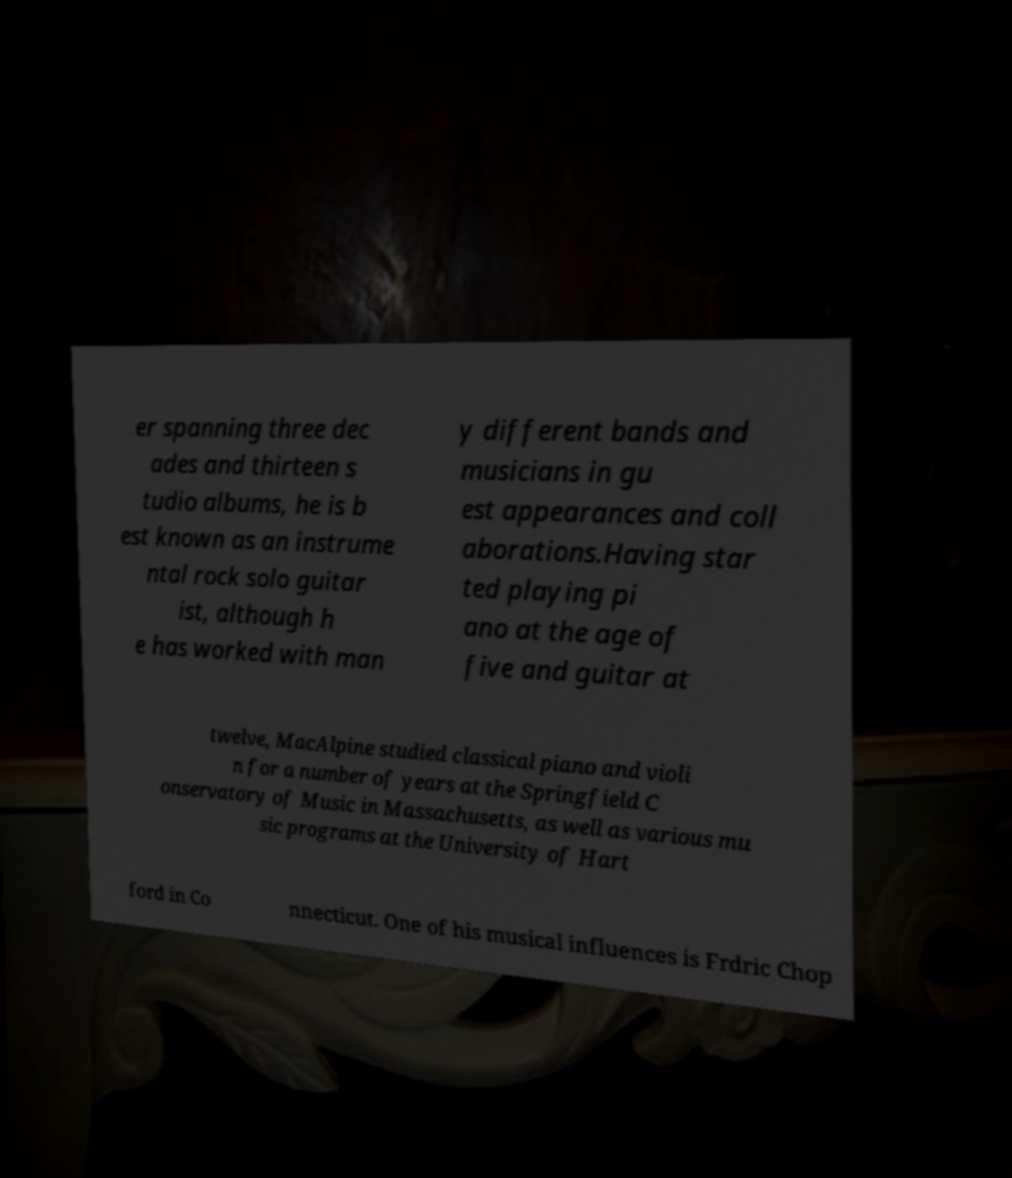Could you assist in decoding the text presented in this image and type it out clearly? er spanning three dec ades and thirteen s tudio albums, he is b est known as an instrume ntal rock solo guitar ist, although h e has worked with man y different bands and musicians in gu est appearances and coll aborations.Having star ted playing pi ano at the age of five and guitar at twelve, MacAlpine studied classical piano and violi n for a number of years at the Springfield C onservatory of Music in Massachusetts, as well as various mu sic programs at the University of Hart ford in Co nnecticut. One of his musical influences is Frdric Chop 